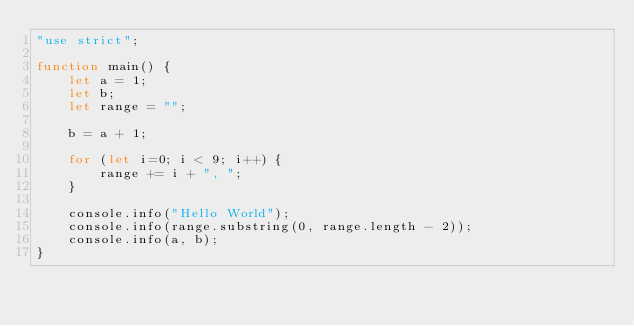Convert code to text. <code><loc_0><loc_0><loc_500><loc_500><_JavaScript_>"use strict";

function main() {
    let a = 1;
    let b;
    let range = "";

    b = a + 1;

    for (let i=0; i < 9; i++) {
        range += i + ", ";
    }

    console.info("Hello World");
    console.info(range.substring(0, range.length - 2));
    console.info(a, b);
}</code> 